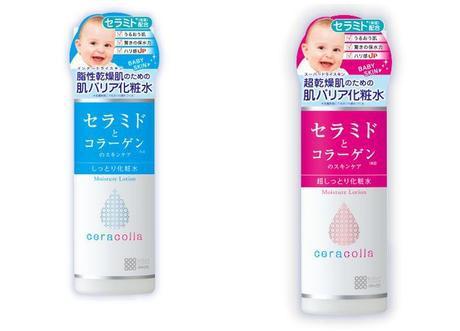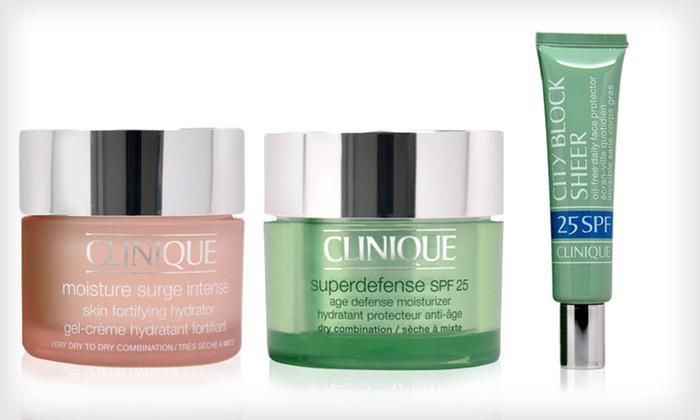The first image is the image on the left, the second image is the image on the right. Assess this claim about the two images: "Each image contains at least three skincare products.". Correct or not? Answer yes or no. No. The first image is the image on the left, the second image is the image on the right. Assess this claim about the two images: "Each image shows at least three plastic bottles of a product in different colors.". Correct or not? Answer yes or no. No. 